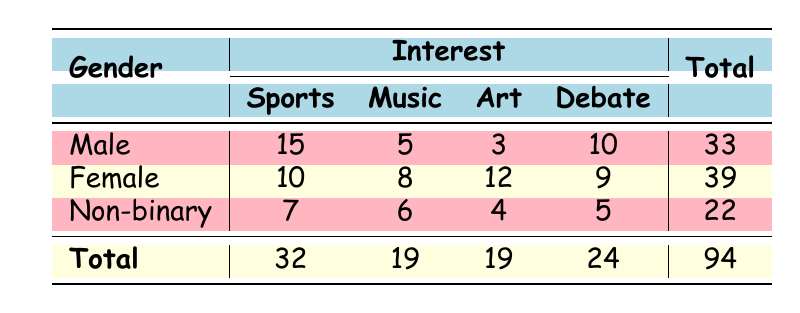What is the total participation in music clubs? By looking at the music column, we can see the participation numbers: Male (5), Female (8), and Non-binary (6). Adding these together: 5 + 8 + 6 = 19.
Answer: 19 How many males are interested in sports? The table indicates that 15 males participate in sports, as shown in the Male row under the Sports column.
Answer: 15 Which interest has the highest participation among females? In the Female row, we see the participation counts for interests: Sports (10), Music (8), Art (12), and Debate (9). The highest is Art with 12 participants.
Answer: Art Is there equal participation in all interests for non-binary students? Looking at the Non-binary row, we have: Sports (7), Music (6), Art (4), and Debate (5). Since these numbers are different, participation is not equal.
Answer: No What is the total participation of females in all clubs? In the Female row, the participation is: Sports (10), Music (8), Art (12), and Debate (9). Adding these values together gives: 10 + 8 + 12 + 9 = 39.
Answer: 39 How many more males participated in sports than non-binary students? From the data, males in sports have 15 participants, while non-binary students have 7. The difference is 15 - 7 = 8.
Answer: 8 What percentage of total participation does male participation represent? The total participation is 94. Male participation is 33. The percentage is calculated as (33 / 94) * 100, approximately equal to 35.11%.
Answer: Approximately 35.11% What is the total participation in sports among all genders? The sports participation counts for each gender are: Male (15), Female (10), and Non-binary (7). Summing these values gives: 15 + 10 + 7 = 32.
Answer: 32 Which group had the least participation in art? Looking at the Art column, we see: Male (3), Female (12), and Non-binary (4). The lowest value is Male with 3 participants.
Answer: Male 